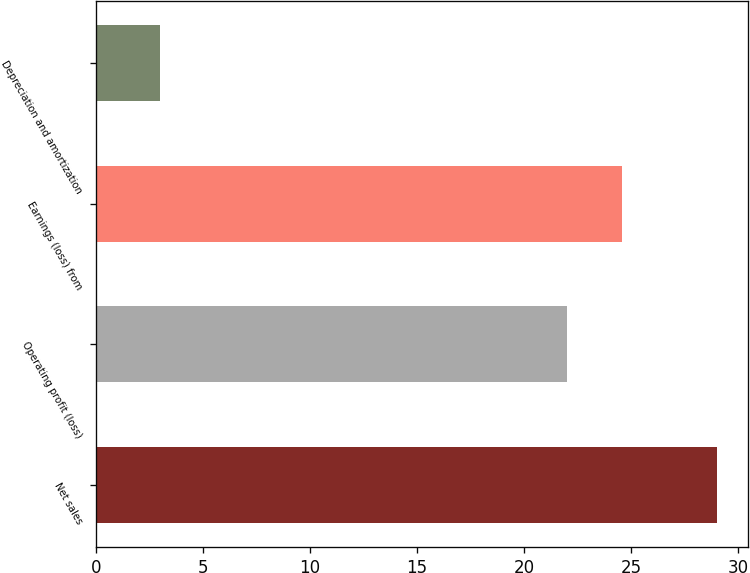<chart> <loc_0><loc_0><loc_500><loc_500><bar_chart><fcel>Net sales<fcel>Operating profit (loss)<fcel>Earnings (loss) from<fcel>Depreciation and amortization<nl><fcel>29<fcel>22<fcel>24.6<fcel>3<nl></chart> 